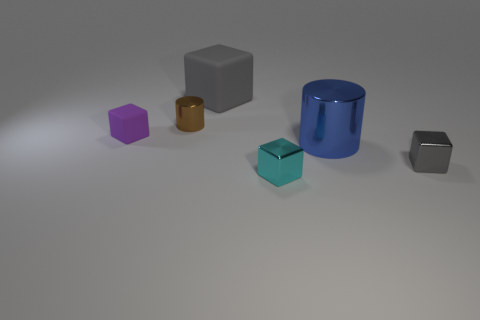What can you infer about the material of the objects? The objects appear to have a smooth, matte finish indicating that they could be made of a solid material like plastic or wood, which is often used in geometric models for educational or display purposes.  Would these objects float if I put them in water? The objects' ability to float would depend on their material density compared to water. Typically, plastic and wood might float, but without specific information, the buoyancy of these objects cannot be determined from the image alone. 